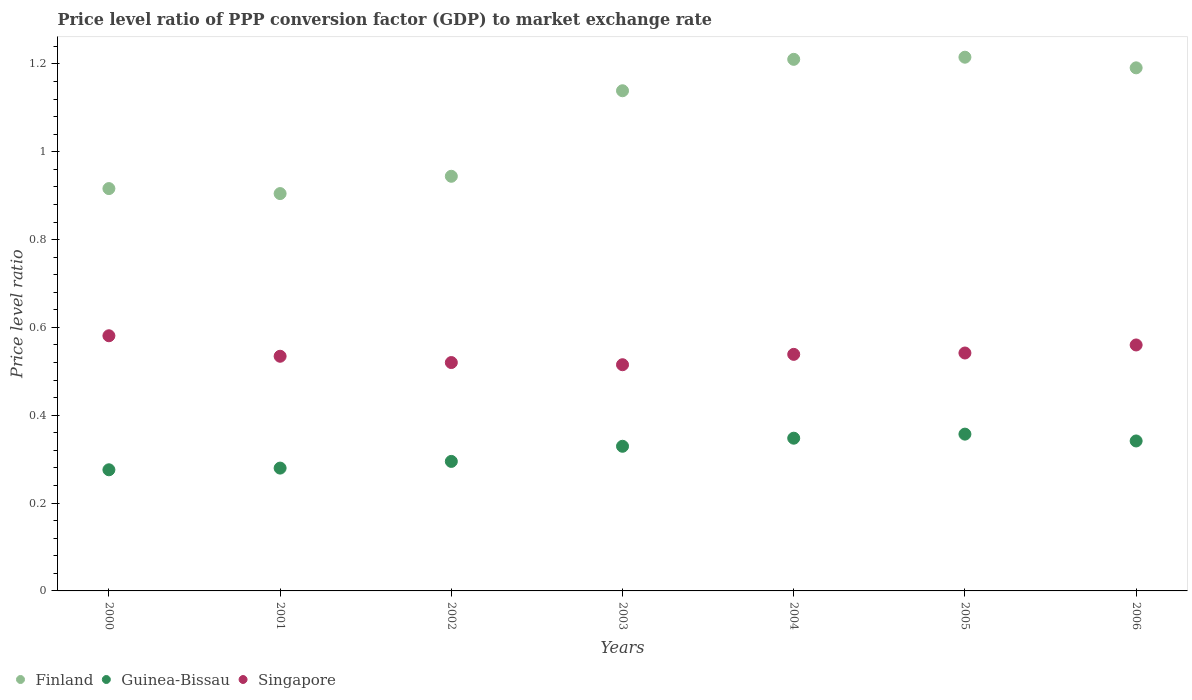Is the number of dotlines equal to the number of legend labels?
Keep it short and to the point. Yes. What is the price level ratio in Singapore in 2002?
Your response must be concise. 0.52. Across all years, what is the maximum price level ratio in Guinea-Bissau?
Provide a short and direct response. 0.36. Across all years, what is the minimum price level ratio in Singapore?
Make the answer very short. 0.52. In which year was the price level ratio in Singapore minimum?
Provide a short and direct response. 2003. What is the total price level ratio in Finland in the graph?
Your answer should be compact. 7.52. What is the difference between the price level ratio in Guinea-Bissau in 2003 and that in 2005?
Your answer should be very brief. -0.03. What is the difference between the price level ratio in Finland in 2006 and the price level ratio in Guinea-Bissau in 2001?
Ensure brevity in your answer.  0.91. What is the average price level ratio in Finland per year?
Your answer should be compact. 1.07. In the year 2000, what is the difference between the price level ratio in Finland and price level ratio in Guinea-Bissau?
Your answer should be compact. 0.64. What is the ratio of the price level ratio in Singapore in 2002 to that in 2004?
Offer a terse response. 0.97. Is the price level ratio in Finland in 2000 less than that in 2006?
Offer a very short reply. Yes. Is the difference between the price level ratio in Finland in 2003 and 2005 greater than the difference between the price level ratio in Guinea-Bissau in 2003 and 2005?
Give a very brief answer. No. What is the difference between the highest and the second highest price level ratio in Singapore?
Ensure brevity in your answer.  0.02. What is the difference between the highest and the lowest price level ratio in Guinea-Bissau?
Provide a short and direct response. 0.08. In how many years, is the price level ratio in Finland greater than the average price level ratio in Finland taken over all years?
Your answer should be compact. 4. Is it the case that in every year, the sum of the price level ratio in Guinea-Bissau and price level ratio in Singapore  is greater than the price level ratio in Finland?
Ensure brevity in your answer.  No. How many years are there in the graph?
Ensure brevity in your answer.  7. What is the difference between two consecutive major ticks on the Y-axis?
Provide a short and direct response. 0.2. Does the graph contain any zero values?
Give a very brief answer. No. Where does the legend appear in the graph?
Your answer should be very brief. Bottom left. What is the title of the graph?
Make the answer very short. Price level ratio of PPP conversion factor (GDP) to market exchange rate. Does "Central African Republic" appear as one of the legend labels in the graph?
Provide a short and direct response. No. What is the label or title of the Y-axis?
Your answer should be very brief. Price level ratio. What is the Price level ratio of Finland in 2000?
Make the answer very short. 0.92. What is the Price level ratio in Guinea-Bissau in 2000?
Give a very brief answer. 0.28. What is the Price level ratio of Singapore in 2000?
Your answer should be very brief. 0.58. What is the Price level ratio in Finland in 2001?
Your answer should be compact. 0.9. What is the Price level ratio in Guinea-Bissau in 2001?
Keep it short and to the point. 0.28. What is the Price level ratio in Singapore in 2001?
Offer a very short reply. 0.53. What is the Price level ratio in Finland in 2002?
Provide a succinct answer. 0.94. What is the Price level ratio of Guinea-Bissau in 2002?
Offer a very short reply. 0.29. What is the Price level ratio of Singapore in 2002?
Your response must be concise. 0.52. What is the Price level ratio in Finland in 2003?
Offer a terse response. 1.14. What is the Price level ratio of Guinea-Bissau in 2003?
Your response must be concise. 0.33. What is the Price level ratio of Singapore in 2003?
Ensure brevity in your answer.  0.52. What is the Price level ratio of Finland in 2004?
Your response must be concise. 1.21. What is the Price level ratio in Guinea-Bissau in 2004?
Ensure brevity in your answer.  0.35. What is the Price level ratio in Singapore in 2004?
Offer a very short reply. 0.54. What is the Price level ratio of Finland in 2005?
Make the answer very short. 1.22. What is the Price level ratio in Guinea-Bissau in 2005?
Provide a short and direct response. 0.36. What is the Price level ratio in Singapore in 2005?
Give a very brief answer. 0.54. What is the Price level ratio in Finland in 2006?
Ensure brevity in your answer.  1.19. What is the Price level ratio of Guinea-Bissau in 2006?
Provide a short and direct response. 0.34. What is the Price level ratio of Singapore in 2006?
Keep it short and to the point. 0.56. Across all years, what is the maximum Price level ratio of Finland?
Offer a very short reply. 1.22. Across all years, what is the maximum Price level ratio of Guinea-Bissau?
Make the answer very short. 0.36. Across all years, what is the maximum Price level ratio in Singapore?
Offer a very short reply. 0.58. Across all years, what is the minimum Price level ratio of Finland?
Make the answer very short. 0.9. Across all years, what is the minimum Price level ratio in Guinea-Bissau?
Your response must be concise. 0.28. Across all years, what is the minimum Price level ratio of Singapore?
Your response must be concise. 0.52. What is the total Price level ratio of Finland in the graph?
Give a very brief answer. 7.52. What is the total Price level ratio in Guinea-Bissau in the graph?
Make the answer very short. 2.23. What is the total Price level ratio in Singapore in the graph?
Provide a succinct answer. 3.79. What is the difference between the Price level ratio of Finland in 2000 and that in 2001?
Your answer should be very brief. 0.01. What is the difference between the Price level ratio in Guinea-Bissau in 2000 and that in 2001?
Make the answer very short. -0. What is the difference between the Price level ratio in Singapore in 2000 and that in 2001?
Offer a terse response. 0.05. What is the difference between the Price level ratio of Finland in 2000 and that in 2002?
Your answer should be very brief. -0.03. What is the difference between the Price level ratio of Guinea-Bissau in 2000 and that in 2002?
Give a very brief answer. -0.02. What is the difference between the Price level ratio in Singapore in 2000 and that in 2002?
Provide a short and direct response. 0.06. What is the difference between the Price level ratio of Finland in 2000 and that in 2003?
Provide a succinct answer. -0.22. What is the difference between the Price level ratio in Guinea-Bissau in 2000 and that in 2003?
Your response must be concise. -0.05. What is the difference between the Price level ratio of Singapore in 2000 and that in 2003?
Offer a very short reply. 0.07. What is the difference between the Price level ratio of Finland in 2000 and that in 2004?
Offer a terse response. -0.29. What is the difference between the Price level ratio in Guinea-Bissau in 2000 and that in 2004?
Ensure brevity in your answer.  -0.07. What is the difference between the Price level ratio in Singapore in 2000 and that in 2004?
Your response must be concise. 0.04. What is the difference between the Price level ratio of Finland in 2000 and that in 2005?
Offer a terse response. -0.3. What is the difference between the Price level ratio in Guinea-Bissau in 2000 and that in 2005?
Give a very brief answer. -0.08. What is the difference between the Price level ratio of Singapore in 2000 and that in 2005?
Ensure brevity in your answer.  0.04. What is the difference between the Price level ratio of Finland in 2000 and that in 2006?
Provide a succinct answer. -0.27. What is the difference between the Price level ratio of Guinea-Bissau in 2000 and that in 2006?
Your response must be concise. -0.07. What is the difference between the Price level ratio of Singapore in 2000 and that in 2006?
Make the answer very short. 0.02. What is the difference between the Price level ratio of Finland in 2001 and that in 2002?
Make the answer very short. -0.04. What is the difference between the Price level ratio in Guinea-Bissau in 2001 and that in 2002?
Offer a terse response. -0.02. What is the difference between the Price level ratio in Singapore in 2001 and that in 2002?
Keep it short and to the point. 0.01. What is the difference between the Price level ratio in Finland in 2001 and that in 2003?
Offer a terse response. -0.23. What is the difference between the Price level ratio of Guinea-Bissau in 2001 and that in 2003?
Keep it short and to the point. -0.05. What is the difference between the Price level ratio of Singapore in 2001 and that in 2003?
Offer a terse response. 0.02. What is the difference between the Price level ratio in Finland in 2001 and that in 2004?
Make the answer very short. -0.31. What is the difference between the Price level ratio in Guinea-Bissau in 2001 and that in 2004?
Make the answer very short. -0.07. What is the difference between the Price level ratio in Singapore in 2001 and that in 2004?
Give a very brief answer. -0. What is the difference between the Price level ratio of Finland in 2001 and that in 2005?
Provide a succinct answer. -0.31. What is the difference between the Price level ratio in Guinea-Bissau in 2001 and that in 2005?
Offer a very short reply. -0.08. What is the difference between the Price level ratio of Singapore in 2001 and that in 2005?
Provide a succinct answer. -0.01. What is the difference between the Price level ratio in Finland in 2001 and that in 2006?
Offer a terse response. -0.29. What is the difference between the Price level ratio of Guinea-Bissau in 2001 and that in 2006?
Give a very brief answer. -0.06. What is the difference between the Price level ratio of Singapore in 2001 and that in 2006?
Your answer should be compact. -0.03. What is the difference between the Price level ratio of Finland in 2002 and that in 2003?
Provide a succinct answer. -0.19. What is the difference between the Price level ratio of Guinea-Bissau in 2002 and that in 2003?
Offer a terse response. -0.03. What is the difference between the Price level ratio in Singapore in 2002 and that in 2003?
Your answer should be very brief. 0.01. What is the difference between the Price level ratio in Finland in 2002 and that in 2004?
Your answer should be very brief. -0.27. What is the difference between the Price level ratio in Guinea-Bissau in 2002 and that in 2004?
Ensure brevity in your answer.  -0.05. What is the difference between the Price level ratio in Singapore in 2002 and that in 2004?
Make the answer very short. -0.02. What is the difference between the Price level ratio of Finland in 2002 and that in 2005?
Your answer should be very brief. -0.27. What is the difference between the Price level ratio of Guinea-Bissau in 2002 and that in 2005?
Keep it short and to the point. -0.06. What is the difference between the Price level ratio of Singapore in 2002 and that in 2005?
Provide a short and direct response. -0.02. What is the difference between the Price level ratio of Finland in 2002 and that in 2006?
Provide a succinct answer. -0.25. What is the difference between the Price level ratio of Guinea-Bissau in 2002 and that in 2006?
Ensure brevity in your answer.  -0.05. What is the difference between the Price level ratio in Singapore in 2002 and that in 2006?
Give a very brief answer. -0.04. What is the difference between the Price level ratio of Finland in 2003 and that in 2004?
Offer a terse response. -0.07. What is the difference between the Price level ratio of Guinea-Bissau in 2003 and that in 2004?
Your answer should be compact. -0.02. What is the difference between the Price level ratio in Singapore in 2003 and that in 2004?
Your answer should be compact. -0.02. What is the difference between the Price level ratio of Finland in 2003 and that in 2005?
Offer a terse response. -0.08. What is the difference between the Price level ratio in Guinea-Bissau in 2003 and that in 2005?
Give a very brief answer. -0.03. What is the difference between the Price level ratio of Singapore in 2003 and that in 2005?
Your response must be concise. -0.03. What is the difference between the Price level ratio of Finland in 2003 and that in 2006?
Make the answer very short. -0.05. What is the difference between the Price level ratio in Guinea-Bissau in 2003 and that in 2006?
Offer a very short reply. -0.01. What is the difference between the Price level ratio in Singapore in 2003 and that in 2006?
Your answer should be compact. -0.04. What is the difference between the Price level ratio in Finland in 2004 and that in 2005?
Your response must be concise. -0. What is the difference between the Price level ratio in Guinea-Bissau in 2004 and that in 2005?
Your answer should be very brief. -0.01. What is the difference between the Price level ratio in Singapore in 2004 and that in 2005?
Ensure brevity in your answer.  -0. What is the difference between the Price level ratio of Finland in 2004 and that in 2006?
Offer a terse response. 0.02. What is the difference between the Price level ratio in Guinea-Bissau in 2004 and that in 2006?
Give a very brief answer. 0.01. What is the difference between the Price level ratio of Singapore in 2004 and that in 2006?
Provide a succinct answer. -0.02. What is the difference between the Price level ratio of Finland in 2005 and that in 2006?
Your answer should be compact. 0.02. What is the difference between the Price level ratio of Guinea-Bissau in 2005 and that in 2006?
Your answer should be compact. 0.02. What is the difference between the Price level ratio of Singapore in 2005 and that in 2006?
Offer a terse response. -0.02. What is the difference between the Price level ratio in Finland in 2000 and the Price level ratio in Guinea-Bissau in 2001?
Offer a terse response. 0.64. What is the difference between the Price level ratio in Finland in 2000 and the Price level ratio in Singapore in 2001?
Your answer should be compact. 0.38. What is the difference between the Price level ratio of Guinea-Bissau in 2000 and the Price level ratio of Singapore in 2001?
Make the answer very short. -0.26. What is the difference between the Price level ratio in Finland in 2000 and the Price level ratio in Guinea-Bissau in 2002?
Offer a very short reply. 0.62. What is the difference between the Price level ratio of Finland in 2000 and the Price level ratio of Singapore in 2002?
Your answer should be very brief. 0.4. What is the difference between the Price level ratio of Guinea-Bissau in 2000 and the Price level ratio of Singapore in 2002?
Your answer should be very brief. -0.24. What is the difference between the Price level ratio in Finland in 2000 and the Price level ratio in Guinea-Bissau in 2003?
Ensure brevity in your answer.  0.59. What is the difference between the Price level ratio of Finland in 2000 and the Price level ratio of Singapore in 2003?
Offer a terse response. 0.4. What is the difference between the Price level ratio in Guinea-Bissau in 2000 and the Price level ratio in Singapore in 2003?
Provide a succinct answer. -0.24. What is the difference between the Price level ratio of Finland in 2000 and the Price level ratio of Guinea-Bissau in 2004?
Offer a terse response. 0.57. What is the difference between the Price level ratio in Finland in 2000 and the Price level ratio in Singapore in 2004?
Offer a terse response. 0.38. What is the difference between the Price level ratio in Guinea-Bissau in 2000 and the Price level ratio in Singapore in 2004?
Offer a terse response. -0.26. What is the difference between the Price level ratio of Finland in 2000 and the Price level ratio of Guinea-Bissau in 2005?
Give a very brief answer. 0.56. What is the difference between the Price level ratio of Finland in 2000 and the Price level ratio of Singapore in 2005?
Give a very brief answer. 0.37. What is the difference between the Price level ratio of Guinea-Bissau in 2000 and the Price level ratio of Singapore in 2005?
Give a very brief answer. -0.27. What is the difference between the Price level ratio in Finland in 2000 and the Price level ratio in Guinea-Bissau in 2006?
Ensure brevity in your answer.  0.57. What is the difference between the Price level ratio of Finland in 2000 and the Price level ratio of Singapore in 2006?
Your response must be concise. 0.36. What is the difference between the Price level ratio in Guinea-Bissau in 2000 and the Price level ratio in Singapore in 2006?
Your answer should be very brief. -0.28. What is the difference between the Price level ratio of Finland in 2001 and the Price level ratio of Guinea-Bissau in 2002?
Your answer should be compact. 0.61. What is the difference between the Price level ratio in Finland in 2001 and the Price level ratio in Singapore in 2002?
Offer a very short reply. 0.38. What is the difference between the Price level ratio in Guinea-Bissau in 2001 and the Price level ratio in Singapore in 2002?
Your answer should be very brief. -0.24. What is the difference between the Price level ratio of Finland in 2001 and the Price level ratio of Guinea-Bissau in 2003?
Keep it short and to the point. 0.58. What is the difference between the Price level ratio of Finland in 2001 and the Price level ratio of Singapore in 2003?
Provide a succinct answer. 0.39. What is the difference between the Price level ratio of Guinea-Bissau in 2001 and the Price level ratio of Singapore in 2003?
Your answer should be very brief. -0.24. What is the difference between the Price level ratio of Finland in 2001 and the Price level ratio of Guinea-Bissau in 2004?
Your response must be concise. 0.56. What is the difference between the Price level ratio in Finland in 2001 and the Price level ratio in Singapore in 2004?
Keep it short and to the point. 0.37. What is the difference between the Price level ratio of Guinea-Bissau in 2001 and the Price level ratio of Singapore in 2004?
Your answer should be compact. -0.26. What is the difference between the Price level ratio of Finland in 2001 and the Price level ratio of Guinea-Bissau in 2005?
Provide a succinct answer. 0.55. What is the difference between the Price level ratio in Finland in 2001 and the Price level ratio in Singapore in 2005?
Provide a succinct answer. 0.36. What is the difference between the Price level ratio of Guinea-Bissau in 2001 and the Price level ratio of Singapore in 2005?
Provide a short and direct response. -0.26. What is the difference between the Price level ratio of Finland in 2001 and the Price level ratio of Guinea-Bissau in 2006?
Ensure brevity in your answer.  0.56. What is the difference between the Price level ratio in Finland in 2001 and the Price level ratio in Singapore in 2006?
Your answer should be very brief. 0.34. What is the difference between the Price level ratio of Guinea-Bissau in 2001 and the Price level ratio of Singapore in 2006?
Your response must be concise. -0.28. What is the difference between the Price level ratio in Finland in 2002 and the Price level ratio in Guinea-Bissau in 2003?
Your response must be concise. 0.61. What is the difference between the Price level ratio of Finland in 2002 and the Price level ratio of Singapore in 2003?
Your answer should be very brief. 0.43. What is the difference between the Price level ratio in Guinea-Bissau in 2002 and the Price level ratio in Singapore in 2003?
Your answer should be compact. -0.22. What is the difference between the Price level ratio of Finland in 2002 and the Price level ratio of Guinea-Bissau in 2004?
Your response must be concise. 0.6. What is the difference between the Price level ratio of Finland in 2002 and the Price level ratio of Singapore in 2004?
Keep it short and to the point. 0.41. What is the difference between the Price level ratio of Guinea-Bissau in 2002 and the Price level ratio of Singapore in 2004?
Offer a very short reply. -0.24. What is the difference between the Price level ratio of Finland in 2002 and the Price level ratio of Guinea-Bissau in 2005?
Offer a very short reply. 0.59. What is the difference between the Price level ratio in Finland in 2002 and the Price level ratio in Singapore in 2005?
Give a very brief answer. 0.4. What is the difference between the Price level ratio of Guinea-Bissau in 2002 and the Price level ratio of Singapore in 2005?
Offer a terse response. -0.25. What is the difference between the Price level ratio in Finland in 2002 and the Price level ratio in Guinea-Bissau in 2006?
Make the answer very short. 0.6. What is the difference between the Price level ratio in Finland in 2002 and the Price level ratio in Singapore in 2006?
Your response must be concise. 0.38. What is the difference between the Price level ratio of Guinea-Bissau in 2002 and the Price level ratio of Singapore in 2006?
Offer a very short reply. -0.27. What is the difference between the Price level ratio in Finland in 2003 and the Price level ratio in Guinea-Bissau in 2004?
Keep it short and to the point. 0.79. What is the difference between the Price level ratio of Finland in 2003 and the Price level ratio of Singapore in 2004?
Your response must be concise. 0.6. What is the difference between the Price level ratio of Guinea-Bissau in 2003 and the Price level ratio of Singapore in 2004?
Your answer should be very brief. -0.21. What is the difference between the Price level ratio in Finland in 2003 and the Price level ratio in Guinea-Bissau in 2005?
Your response must be concise. 0.78. What is the difference between the Price level ratio of Finland in 2003 and the Price level ratio of Singapore in 2005?
Your answer should be compact. 0.6. What is the difference between the Price level ratio in Guinea-Bissau in 2003 and the Price level ratio in Singapore in 2005?
Make the answer very short. -0.21. What is the difference between the Price level ratio of Finland in 2003 and the Price level ratio of Guinea-Bissau in 2006?
Your answer should be very brief. 0.8. What is the difference between the Price level ratio of Finland in 2003 and the Price level ratio of Singapore in 2006?
Offer a very short reply. 0.58. What is the difference between the Price level ratio in Guinea-Bissau in 2003 and the Price level ratio in Singapore in 2006?
Your answer should be compact. -0.23. What is the difference between the Price level ratio in Finland in 2004 and the Price level ratio in Guinea-Bissau in 2005?
Offer a very short reply. 0.85. What is the difference between the Price level ratio of Finland in 2004 and the Price level ratio of Singapore in 2005?
Keep it short and to the point. 0.67. What is the difference between the Price level ratio of Guinea-Bissau in 2004 and the Price level ratio of Singapore in 2005?
Offer a very short reply. -0.19. What is the difference between the Price level ratio in Finland in 2004 and the Price level ratio in Guinea-Bissau in 2006?
Provide a short and direct response. 0.87. What is the difference between the Price level ratio in Finland in 2004 and the Price level ratio in Singapore in 2006?
Provide a short and direct response. 0.65. What is the difference between the Price level ratio in Guinea-Bissau in 2004 and the Price level ratio in Singapore in 2006?
Offer a very short reply. -0.21. What is the difference between the Price level ratio in Finland in 2005 and the Price level ratio in Guinea-Bissau in 2006?
Keep it short and to the point. 0.87. What is the difference between the Price level ratio of Finland in 2005 and the Price level ratio of Singapore in 2006?
Your answer should be very brief. 0.66. What is the difference between the Price level ratio in Guinea-Bissau in 2005 and the Price level ratio in Singapore in 2006?
Keep it short and to the point. -0.2. What is the average Price level ratio in Finland per year?
Your response must be concise. 1.07. What is the average Price level ratio in Guinea-Bissau per year?
Give a very brief answer. 0.32. What is the average Price level ratio in Singapore per year?
Offer a terse response. 0.54. In the year 2000, what is the difference between the Price level ratio in Finland and Price level ratio in Guinea-Bissau?
Your answer should be compact. 0.64. In the year 2000, what is the difference between the Price level ratio in Finland and Price level ratio in Singapore?
Make the answer very short. 0.34. In the year 2000, what is the difference between the Price level ratio of Guinea-Bissau and Price level ratio of Singapore?
Make the answer very short. -0.31. In the year 2001, what is the difference between the Price level ratio in Finland and Price level ratio in Guinea-Bissau?
Provide a short and direct response. 0.63. In the year 2001, what is the difference between the Price level ratio in Finland and Price level ratio in Singapore?
Provide a short and direct response. 0.37. In the year 2001, what is the difference between the Price level ratio in Guinea-Bissau and Price level ratio in Singapore?
Ensure brevity in your answer.  -0.25. In the year 2002, what is the difference between the Price level ratio in Finland and Price level ratio in Guinea-Bissau?
Offer a terse response. 0.65. In the year 2002, what is the difference between the Price level ratio in Finland and Price level ratio in Singapore?
Provide a succinct answer. 0.42. In the year 2002, what is the difference between the Price level ratio in Guinea-Bissau and Price level ratio in Singapore?
Your answer should be very brief. -0.23. In the year 2003, what is the difference between the Price level ratio of Finland and Price level ratio of Guinea-Bissau?
Ensure brevity in your answer.  0.81. In the year 2003, what is the difference between the Price level ratio of Finland and Price level ratio of Singapore?
Your answer should be very brief. 0.62. In the year 2003, what is the difference between the Price level ratio in Guinea-Bissau and Price level ratio in Singapore?
Ensure brevity in your answer.  -0.19. In the year 2004, what is the difference between the Price level ratio in Finland and Price level ratio in Guinea-Bissau?
Ensure brevity in your answer.  0.86. In the year 2004, what is the difference between the Price level ratio of Finland and Price level ratio of Singapore?
Your answer should be very brief. 0.67. In the year 2004, what is the difference between the Price level ratio of Guinea-Bissau and Price level ratio of Singapore?
Your response must be concise. -0.19. In the year 2005, what is the difference between the Price level ratio of Finland and Price level ratio of Guinea-Bissau?
Your answer should be compact. 0.86. In the year 2005, what is the difference between the Price level ratio of Finland and Price level ratio of Singapore?
Your response must be concise. 0.67. In the year 2005, what is the difference between the Price level ratio in Guinea-Bissau and Price level ratio in Singapore?
Give a very brief answer. -0.18. In the year 2006, what is the difference between the Price level ratio of Finland and Price level ratio of Guinea-Bissau?
Your answer should be compact. 0.85. In the year 2006, what is the difference between the Price level ratio of Finland and Price level ratio of Singapore?
Your answer should be compact. 0.63. In the year 2006, what is the difference between the Price level ratio in Guinea-Bissau and Price level ratio in Singapore?
Your answer should be very brief. -0.22. What is the ratio of the Price level ratio in Finland in 2000 to that in 2001?
Make the answer very short. 1.01. What is the ratio of the Price level ratio in Guinea-Bissau in 2000 to that in 2001?
Provide a short and direct response. 0.99. What is the ratio of the Price level ratio in Singapore in 2000 to that in 2001?
Keep it short and to the point. 1.09. What is the ratio of the Price level ratio of Finland in 2000 to that in 2002?
Ensure brevity in your answer.  0.97. What is the ratio of the Price level ratio in Guinea-Bissau in 2000 to that in 2002?
Your response must be concise. 0.94. What is the ratio of the Price level ratio of Singapore in 2000 to that in 2002?
Provide a short and direct response. 1.12. What is the ratio of the Price level ratio in Finland in 2000 to that in 2003?
Your response must be concise. 0.8. What is the ratio of the Price level ratio of Guinea-Bissau in 2000 to that in 2003?
Provide a succinct answer. 0.84. What is the ratio of the Price level ratio of Singapore in 2000 to that in 2003?
Provide a short and direct response. 1.13. What is the ratio of the Price level ratio of Finland in 2000 to that in 2004?
Your answer should be compact. 0.76. What is the ratio of the Price level ratio in Guinea-Bissau in 2000 to that in 2004?
Keep it short and to the point. 0.79. What is the ratio of the Price level ratio of Singapore in 2000 to that in 2004?
Give a very brief answer. 1.08. What is the ratio of the Price level ratio of Finland in 2000 to that in 2005?
Keep it short and to the point. 0.75. What is the ratio of the Price level ratio of Guinea-Bissau in 2000 to that in 2005?
Your response must be concise. 0.77. What is the ratio of the Price level ratio in Singapore in 2000 to that in 2005?
Offer a very short reply. 1.07. What is the ratio of the Price level ratio in Finland in 2000 to that in 2006?
Your response must be concise. 0.77. What is the ratio of the Price level ratio of Guinea-Bissau in 2000 to that in 2006?
Your answer should be very brief. 0.81. What is the ratio of the Price level ratio of Singapore in 2000 to that in 2006?
Provide a short and direct response. 1.04. What is the ratio of the Price level ratio of Guinea-Bissau in 2001 to that in 2002?
Make the answer very short. 0.95. What is the ratio of the Price level ratio of Singapore in 2001 to that in 2002?
Ensure brevity in your answer.  1.03. What is the ratio of the Price level ratio in Finland in 2001 to that in 2003?
Offer a very short reply. 0.79. What is the ratio of the Price level ratio in Guinea-Bissau in 2001 to that in 2003?
Provide a succinct answer. 0.85. What is the ratio of the Price level ratio of Singapore in 2001 to that in 2003?
Make the answer very short. 1.04. What is the ratio of the Price level ratio in Finland in 2001 to that in 2004?
Your answer should be very brief. 0.75. What is the ratio of the Price level ratio in Guinea-Bissau in 2001 to that in 2004?
Your response must be concise. 0.8. What is the ratio of the Price level ratio of Finland in 2001 to that in 2005?
Your response must be concise. 0.74. What is the ratio of the Price level ratio of Guinea-Bissau in 2001 to that in 2005?
Keep it short and to the point. 0.78. What is the ratio of the Price level ratio of Singapore in 2001 to that in 2005?
Give a very brief answer. 0.99. What is the ratio of the Price level ratio of Finland in 2001 to that in 2006?
Your answer should be very brief. 0.76. What is the ratio of the Price level ratio in Guinea-Bissau in 2001 to that in 2006?
Provide a short and direct response. 0.82. What is the ratio of the Price level ratio in Singapore in 2001 to that in 2006?
Your response must be concise. 0.95. What is the ratio of the Price level ratio in Finland in 2002 to that in 2003?
Provide a succinct answer. 0.83. What is the ratio of the Price level ratio of Guinea-Bissau in 2002 to that in 2003?
Provide a short and direct response. 0.9. What is the ratio of the Price level ratio of Singapore in 2002 to that in 2003?
Make the answer very short. 1.01. What is the ratio of the Price level ratio of Finland in 2002 to that in 2004?
Your answer should be very brief. 0.78. What is the ratio of the Price level ratio in Guinea-Bissau in 2002 to that in 2004?
Keep it short and to the point. 0.85. What is the ratio of the Price level ratio of Singapore in 2002 to that in 2004?
Your answer should be very brief. 0.97. What is the ratio of the Price level ratio of Finland in 2002 to that in 2005?
Your answer should be very brief. 0.78. What is the ratio of the Price level ratio of Guinea-Bissau in 2002 to that in 2005?
Make the answer very short. 0.83. What is the ratio of the Price level ratio of Singapore in 2002 to that in 2005?
Give a very brief answer. 0.96. What is the ratio of the Price level ratio in Finland in 2002 to that in 2006?
Give a very brief answer. 0.79. What is the ratio of the Price level ratio of Guinea-Bissau in 2002 to that in 2006?
Offer a very short reply. 0.86. What is the ratio of the Price level ratio of Singapore in 2002 to that in 2006?
Provide a succinct answer. 0.93. What is the ratio of the Price level ratio of Finland in 2003 to that in 2004?
Your answer should be very brief. 0.94. What is the ratio of the Price level ratio in Guinea-Bissau in 2003 to that in 2004?
Offer a very short reply. 0.95. What is the ratio of the Price level ratio in Singapore in 2003 to that in 2004?
Keep it short and to the point. 0.96. What is the ratio of the Price level ratio in Finland in 2003 to that in 2005?
Ensure brevity in your answer.  0.94. What is the ratio of the Price level ratio of Guinea-Bissau in 2003 to that in 2005?
Offer a terse response. 0.92. What is the ratio of the Price level ratio of Singapore in 2003 to that in 2005?
Provide a succinct answer. 0.95. What is the ratio of the Price level ratio in Finland in 2003 to that in 2006?
Provide a succinct answer. 0.96. What is the ratio of the Price level ratio of Guinea-Bissau in 2003 to that in 2006?
Your answer should be compact. 0.96. What is the ratio of the Price level ratio in Singapore in 2003 to that in 2006?
Keep it short and to the point. 0.92. What is the ratio of the Price level ratio of Guinea-Bissau in 2004 to that in 2005?
Your response must be concise. 0.97. What is the ratio of the Price level ratio of Finland in 2004 to that in 2006?
Offer a very short reply. 1.02. What is the ratio of the Price level ratio of Guinea-Bissau in 2004 to that in 2006?
Provide a short and direct response. 1.02. What is the ratio of the Price level ratio in Singapore in 2004 to that in 2006?
Make the answer very short. 0.96. What is the ratio of the Price level ratio of Finland in 2005 to that in 2006?
Offer a very short reply. 1.02. What is the ratio of the Price level ratio in Guinea-Bissau in 2005 to that in 2006?
Ensure brevity in your answer.  1.05. What is the ratio of the Price level ratio in Singapore in 2005 to that in 2006?
Give a very brief answer. 0.97. What is the difference between the highest and the second highest Price level ratio in Finland?
Provide a succinct answer. 0. What is the difference between the highest and the second highest Price level ratio of Guinea-Bissau?
Make the answer very short. 0.01. What is the difference between the highest and the second highest Price level ratio in Singapore?
Make the answer very short. 0.02. What is the difference between the highest and the lowest Price level ratio of Finland?
Provide a short and direct response. 0.31. What is the difference between the highest and the lowest Price level ratio in Guinea-Bissau?
Your response must be concise. 0.08. What is the difference between the highest and the lowest Price level ratio of Singapore?
Make the answer very short. 0.07. 